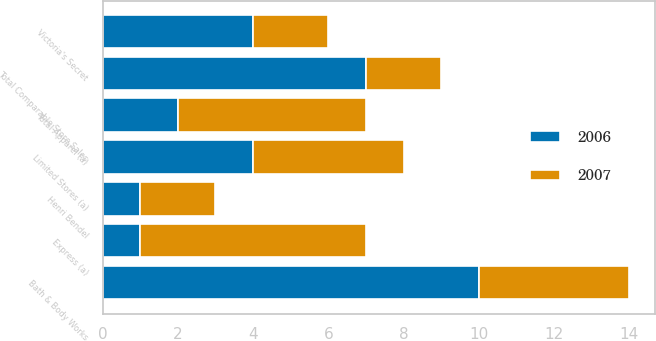Convert chart to OTSL. <chart><loc_0><loc_0><loc_500><loc_500><stacked_bar_chart><ecel><fcel>Victoria's Secret<fcel>Bath & Body Works<fcel>Express (a)<fcel>Limited Stores (a)<fcel>Total Apparel (a)<fcel>Henri Bendel<fcel>Total Comparable Store Sales<nl><fcel>2007<fcel>2<fcel>4<fcel>6<fcel>4<fcel>5<fcel>2<fcel>2<nl><fcel>2006<fcel>4<fcel>10<fcel>1<fcel>4<fcel>2<fcel>1<fcel>7<nl></chart> 